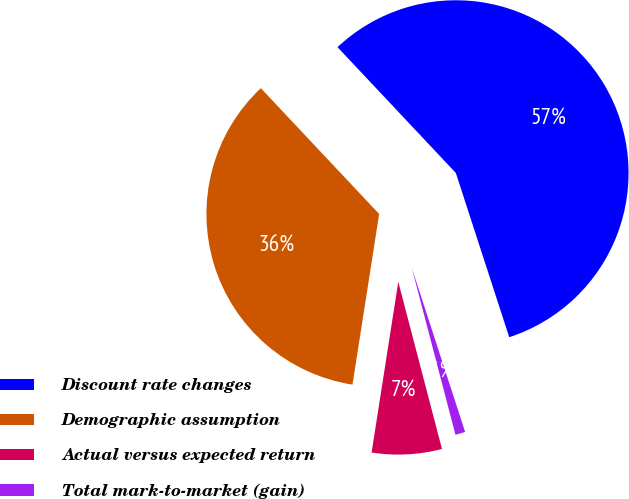<chart> <loc_0><loc_0><loc_500><loc_500><pie_chart><fcel>Discount rate changes<fcel>Demographic assumption<fcel>Actual versus expected return<fcel>Total mark-to-market (gain)<nl><fcel>57.01%<fcel>35.52%<fcel>6.54%<fcel>0.93%<nl></chart> 